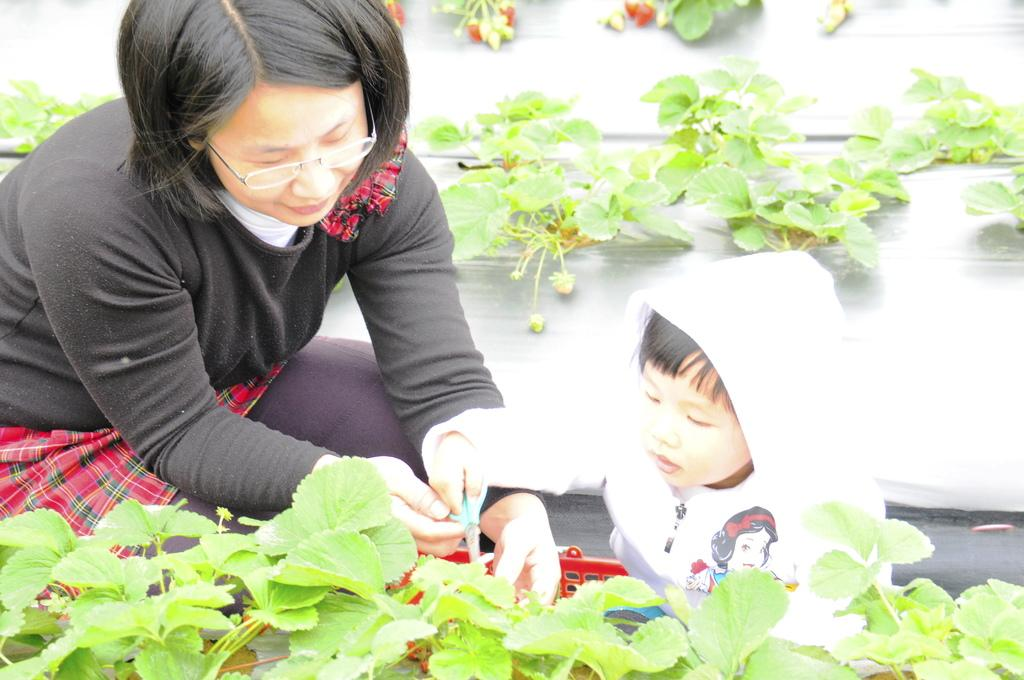Who is present in the image? There is a woman and a kid in the image. What are the woman and the kid holding in the image? Both the woman and the kid are holding scissors in the image. What can be seen in the image besides the woman and the kid? There is a basket and plants visible in the image. Where are the plants located in the image? The plants are visible at the bottom and in the background of the image. What type of bean is being roasted in the campfire in the image? There is no campfire or bean present in the image; it features a woman, a kid, scissors, a basket, and plants. 